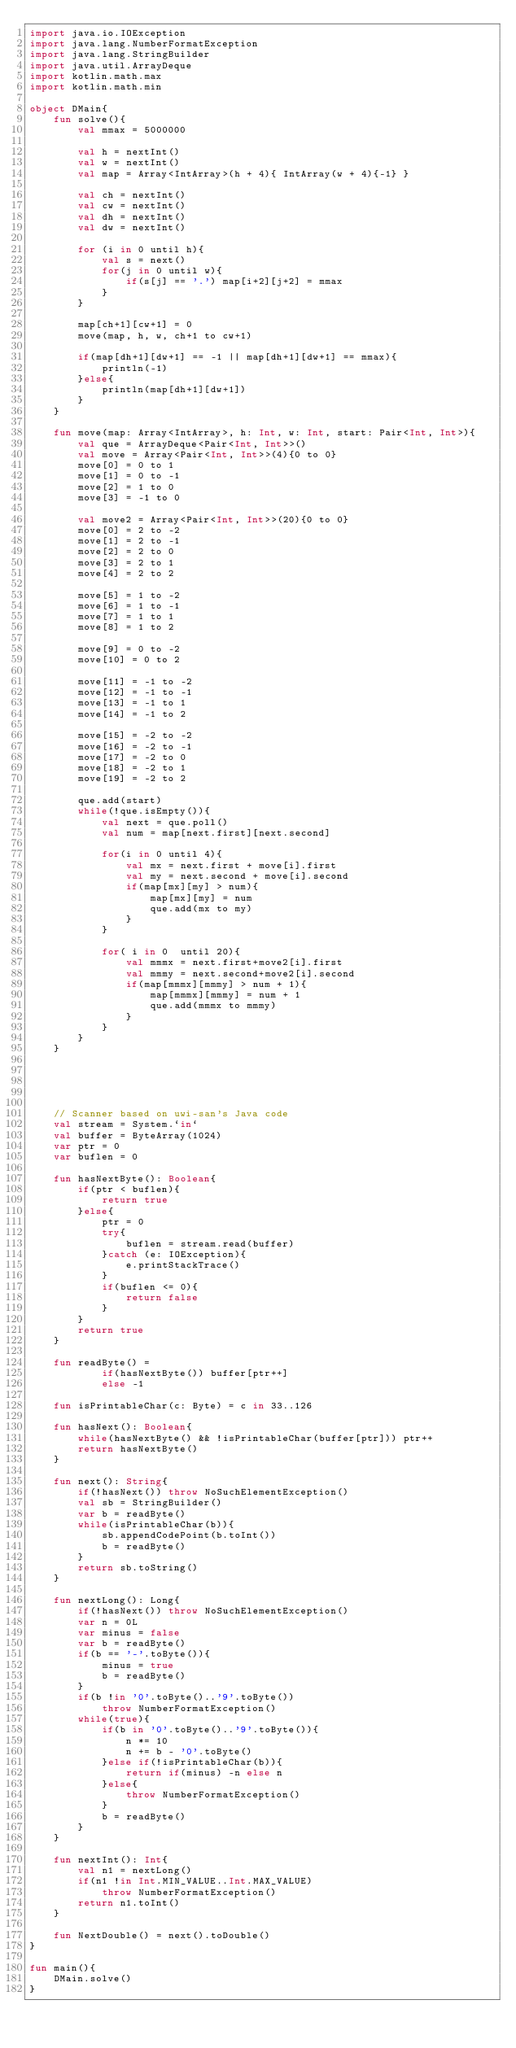Convert code to text. <code><loc_0><loc_0><loc_500><loc_500><_Kotlin_>import java.io.IOException
import java.lang.NumberFormatException
import java.lang.StringBuilder
import java.util.ArrayDeque
import kotlin.math.max
import kotlin.math.min

object DMain{
    fun solve(){
        val mmax = 5000000

        val h = nextInt()
        val w = nextInt()
        val map = Array<IntArray>(h + 4){ IntArray(w + 4){-1} }

        val ch = nextInt()
        val cw = nextInt()
        val dh = nextInt()
        val dw = nextInt()

        for (i in 0 until h){
            val s = next()
            for(j in 0 until w){
                if(s[j] == '.') map[i+2][j+2] = mmax
            }
        }

        map[ch+1][cw+1] = 0
        move(map, h, w, ch+1 to cw+1)

        if(map[dh+1][dw+1] == -1 || map[dh+1][dw+1] == mmax){
            println(-1)
        }else{
            println(map[dh+1][dw+1])
        }
    }

    fun move(map: Array<IntArray>, h: Int, w: Int, start: Pair<Int, Int>){
        val que = ArrayDeque<Pair<Int, Int>>()
        val move = Array<Pair<Int, Int>>(4){0 to 0}
        move[0] = 0 to 1
        move[1] = 0 to -1
        move[2] = 1 to 0
        move[3] = -1 to 0

        val move2 = Array<Pair<Int, Int>>(20){0 to 0}
        move[0] = 2 to -2
        move[1] = 2 to -1
        move[2] = 2 to 0
        move[3] = 2 to 1
        move[4] = 2 to 2

        move[5] = 1 to -2
        move[6] = 1 to -1
        move[7] = 1 to 1
        move[8] = 1 to 2

        move[9] = 0 to -2
        move[10] = 0 to 2

        move[11] = -1 to -2
        move[12] = -1 to -1
        move[13] = -1 to 1
        move[14] = -1 to 2

        move[15] = -2 to -2
        move[16] = -2 to -1
        move[17] = -2 to 0
        move[18] = -2 to 1
        move[19] = -2 to 2

        que.add(start)
        while(!que.isEmpty()){
            val next = que.poll()
            val num = map[next.first][next.second]

            for(i in 0 until 4){
                val mx = next.first + move[i].first
                val my = next.second + move[i].second
                if(map[mx][my] > num){
                    map[mx][my] = num
                    que.add(mx to my)
                }
            }

            for( i in 0  until 20){
                val mmmx = next.first+move2[i].first
                val mmmy = next.second+move2[i].second
                if(map[mmmx][mmmy] > num + 1){
                    map[mmmx][mmmy] = num + 1
                    que.add(mmmx to mmmy)
                }
            }
        }
    }





    // Scanner based on uwi-san's Java code
    val stream = System.`in`
    val buffer = ByteArray(1024)
    var ptr = 0
    var buflen = 0

    fun hasNextByte(): Boolean{
        if(ptr < buflen){
            return true
        }else{
            ptr = 0
            try{
                buflen = stream.read(buffer)
            }catch (e: IOException){
                e.printStackTrace()
            }
            if(buflen <= 0){
                return false
            }
        }
        return true
    }

    fun readByte() =
            if(hasNextByte()) buffer[ptr++]
            else -1

    fun isPrintableChar(c: Byte) = c in 33..126

    fun hasNext(): Boolean{
        while(hasNextByte() && !isPrintableChar(buffer[ptr])) ptr++
        return hasNextByte()
    }

    fun next(): String{
        if(!hasNext()) throw NoSuchElementException()
        val sb = StringBuilder()
        var b = readByte()
        while(isPrintableChar(b)){
            sb.appendCodePoint(b.toInt())
            b = readByte()
        }
        return sb.toString()
    }

    fun nextLong(): Long{
        if(!hasNext()) throw NoSuchElementException()
        var n = 0L
        var minus = false
        var b = readByte()
        if(b == '-'.toByte()){
            minus = true
            b = readByte()
        }
        if(b !in '0'.toByte()..'9'.toByte())
            throw NumberFormatException()
        while(true){
            if(b in '0'.toByte()..'9'.toByte()){
                n *= 10
                n += b - '0'.toByte()
            }else if(!isPrintableChar(b)){
                return if(minus) -n else n
            }else{
                throw NumberFormatException()
            }
            b = readByte()
        }
    }

    fun nextInt(): Int{
        val n1 = nextLong()
        if(n1 !in Int.MIN_VALUE..Int.MAX_VALUE)
            throw NumberFormatException()
        return n1.toInt()
    }

    fun NextDouble() = next().toDouble()
}

fun main(){
    DMain.solve()
}
</code> 